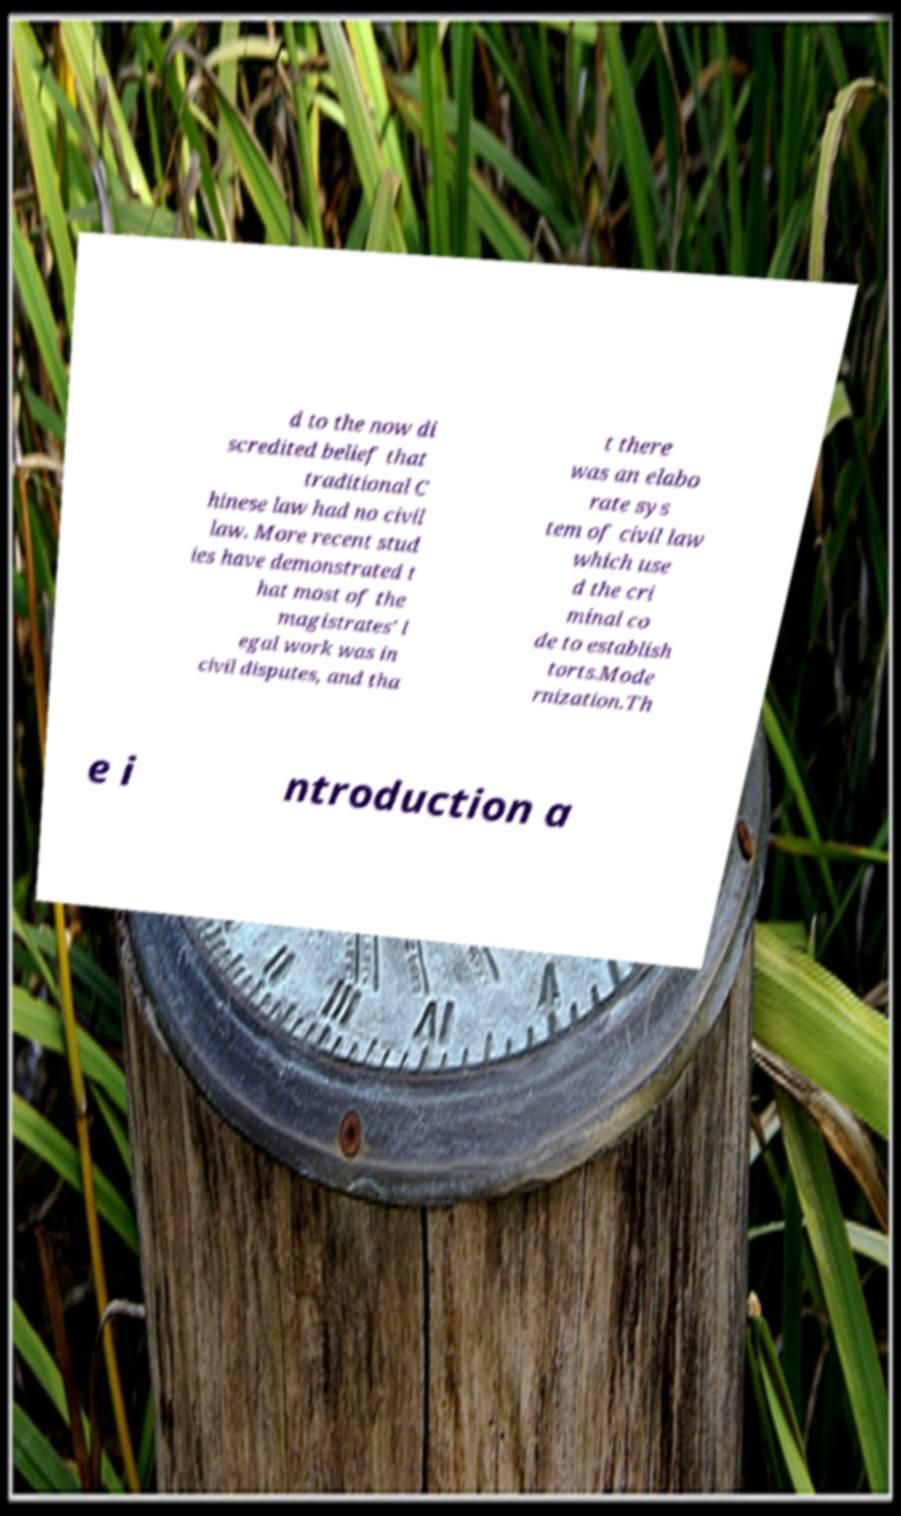I need the written content from this picture converted into text. Can you do that? d to the now di scredited belief that traditional C hinese law had no civil law. More recent stud ies have demonstrated t hat most of the magistrates' l egal work was in civil disputes, and tha t there was an elabo rate sys tem of civil law which use d the cri minal co de to establish torts.Mode rnization.Th e i ntroduction a 